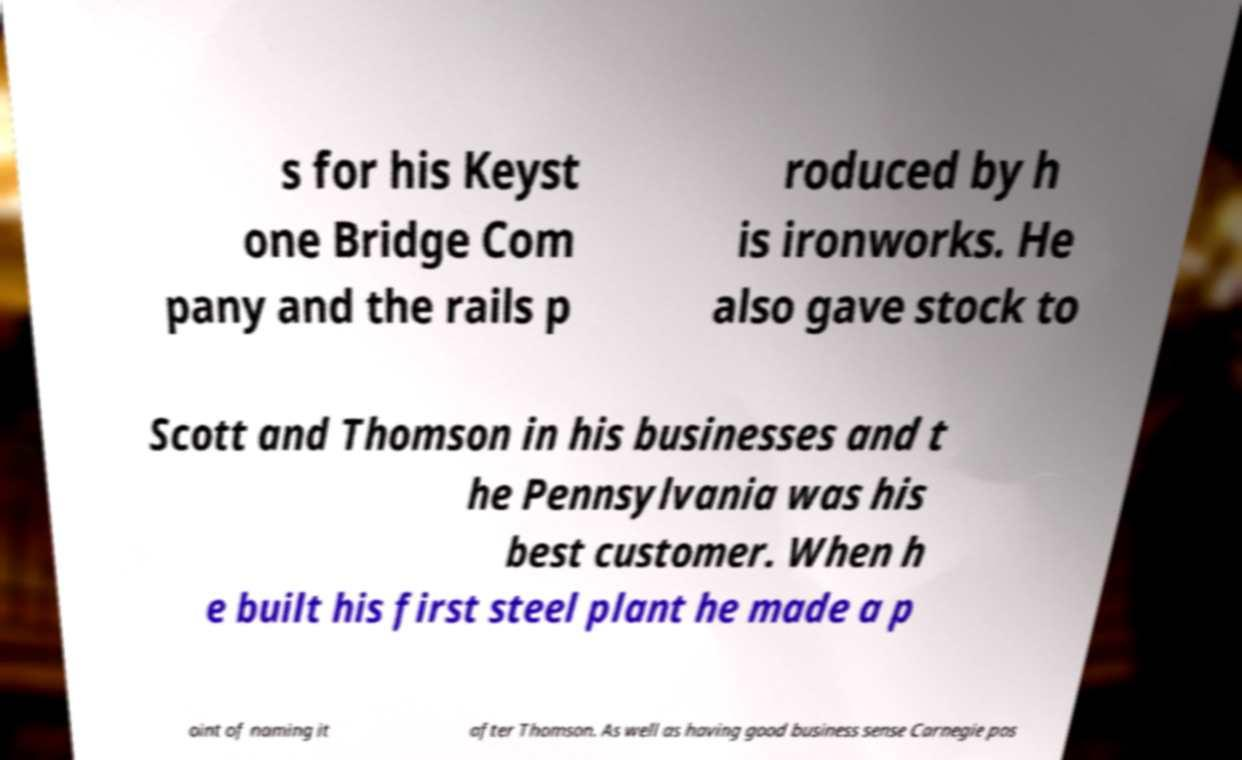For documentation purposes, I need the text within this image transcribed. Could you provide that? s for his Keyst one Bridge Com pany and the rails p roduced by h is ironworks. He also gave stock to Scott and Thomson in his businesses and t he Pennsylvania was his best customer. When h e built his first steel plant he made a p oint of naming it after Thomson. As well as having good business sense Carnegie pos 